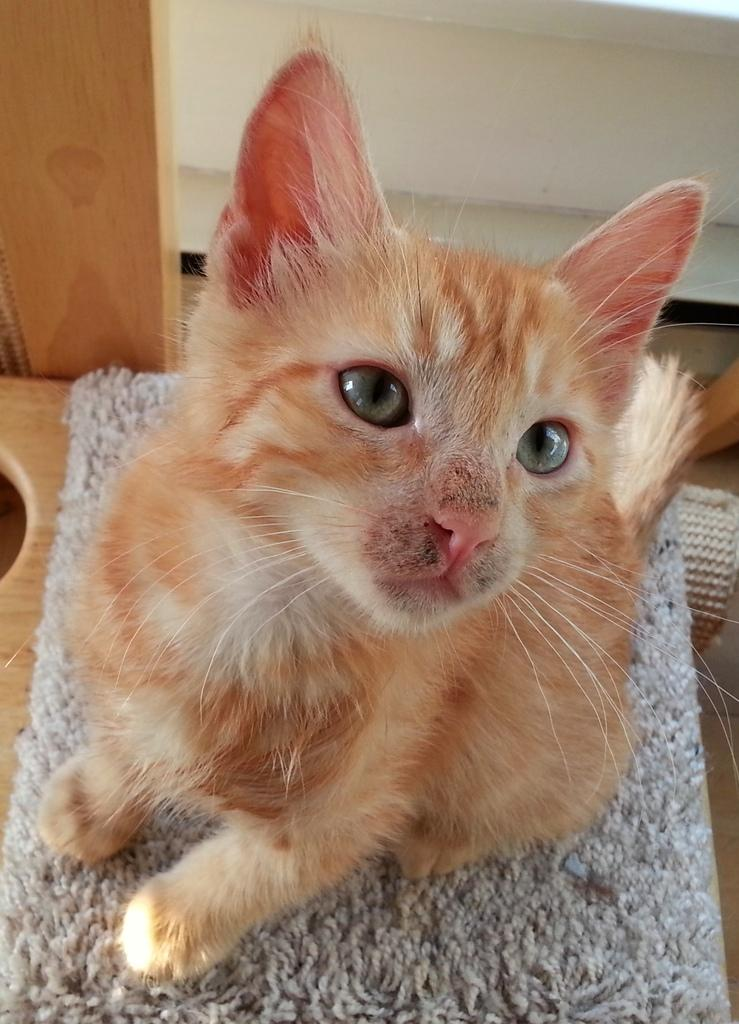What animal is present in the image? There is a cat in the image. Where is the cat located? The cat is on a mat. What is the mat placed on? The mat is on a table. What can be seen in the background of the image? There is a wall and a wooden object visible in the background. What type of twig is the cat holding in its paw in the image? There is no twig present in the image; the cat is not holding anything in its paw. How many friends does the cat have in the image? The image does not show any friends of the cat, as it is focused on the cat and its surroundings. 